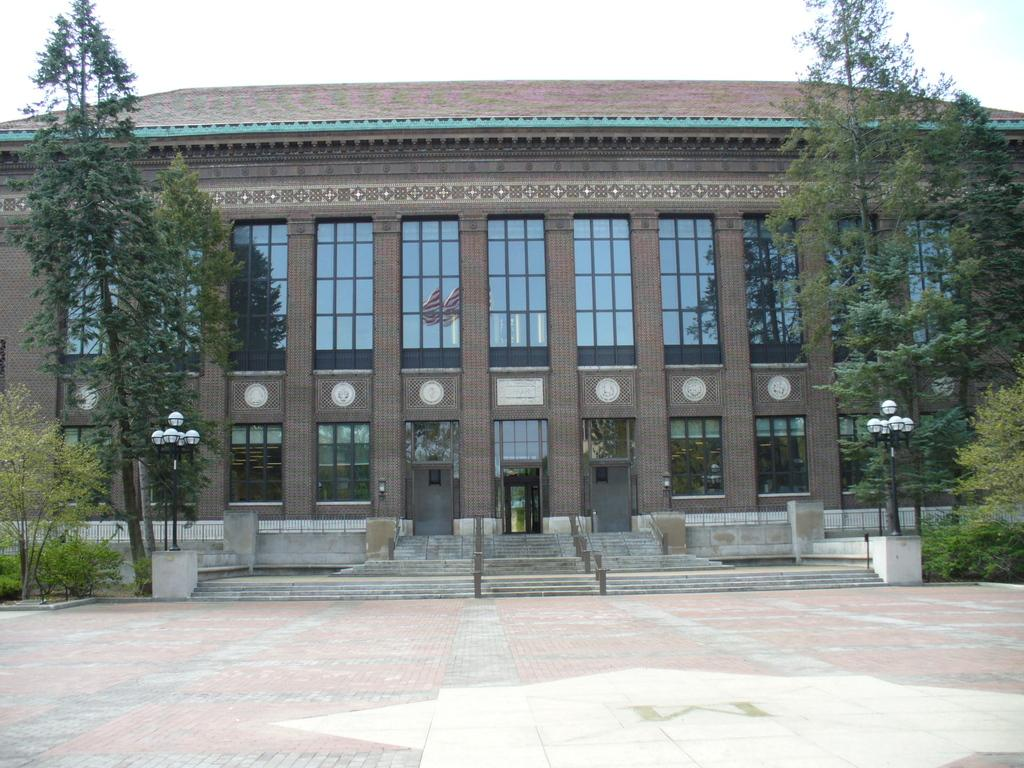What is the main structure in the center of the image? There is a building in the center of the image. What architectural feature is located in front of the building? There are stairs in front of the building. What additional elements are present in front of the building? There are lights, flags, and trees in front of the building. What can be seen in the background of the image? The sky is visible in the background of the image. What type of kitty can be seen climbing the building in the image? There is no kitty present in the image; it only features a building, stairs, lights, flags, trees, and the sky. How much does the quarter cost in the image? There is no mention of a quarter or any currency in the image. 